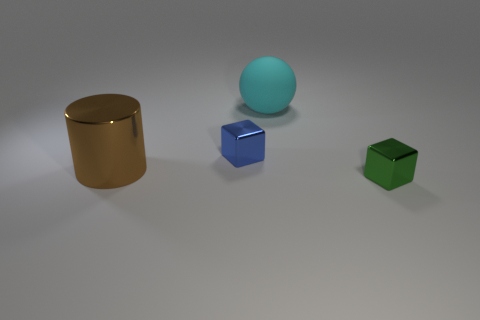How many blue objects have the same shape as the green metal thing?
Make the answer very short. 1. There is a cube that is left of the small cube that is in front of the small metal cube that is to the left of the green object; what size is it?
Your response must be concise. Small. How many blue things are either blocks or large shiny objects?
Provide a succinct answer. 1. Is the shape of the small thing that is behind the large metallic thing the same as  the cyan matte thing?
Your response must be concise. No. Is the number of small blue metallic objects behind the blue shiny thing greater than the number of shiny cylinders?
Give a very brief answer. No. What number of other blue metallic objects are the same size as the blue shiny object?
Your answer should be very brief. 0. How many objects are red things or metallic cubes to the left of the small green thing?
Give a very brief answer. 1. What color is the object that is in front of the blue thing and on the left side of the cyan matte ball?
Make the answer very short. Brown. Do the sphere and the blue metal object have the same size?
Give a very brief answer. No. There is a metallic thing behind the brown thing; what color is it?
Your answer should be compact. Blue. 